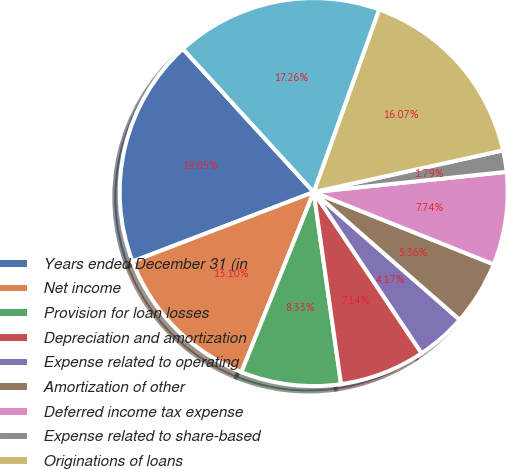Convert chart to OTSL. <chart><loc_0><loc_0><loc_500><loc_500><pie_chart><fcel>Years ended December 31 (in<fcel>Net income<fcel>Provision for loan losses<fcel>Depreciation and amortization<fcel>Expense related to operating<fcel>Amortization of other<fcel>Deferred income tax expense<fcel>Expense related to share-based<fcel>Originations of loans<fcel>Proceeds from sales of loans<nl><fcel>19.05%<fcel>13.1%<fcel>8.33%<fcel>7.14%<fcel>4.17%<fcel>5.36%<fcel>7.74%<fcel>1.79%<fcel>16.07%<fcel>17.26%<nl></chart> 